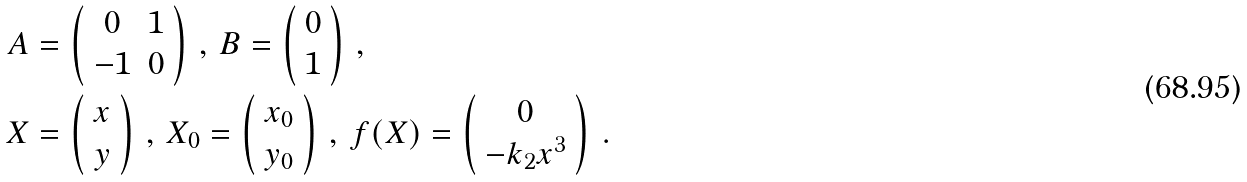Convert formula to latex. <formula><loc_0><loc_0><loc_500><loc_500>A & = \left ( \begin{array} { c c } 0 & 1 \\ - 1 & 0 \end{array} \right ) \, , \, B = \left ( \begin{array} { c } 0 \\ 1 \end{array} \right ) \, , \\ X & = \left ( \begin{array} { c } x \\ y \end{array} \right ) \, , \, X _ { 0 } = \left ( \begin{array} { c } x _ { 0 } \\ y _ { 0 } \end{array} \right ) \, , \, f ( X ) = \left ( \begin{array} { c } 0 \\ - k _ { 2 } x ^ { 3 } \end{array} \right ) \, .</formula> 